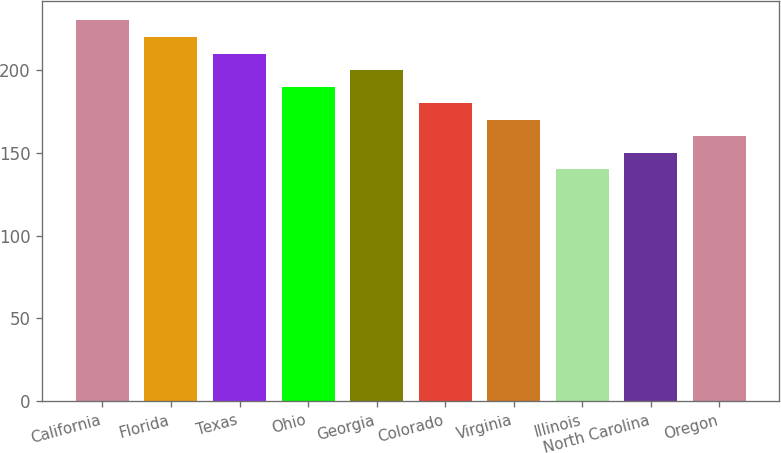<chart> <loc_0><loc_0><loc_500><loc_500><bar_chart><fcel>California<fcel>Florida<fcel>Texas<fcel>Ohio<fcel>Georgia<fcel>Colorado<fcel>Virginia<fcel>Illinois<fcel>North Carolina<fcel>Oregon<nl><fcel>229.87<fcel>219.88<fcel>209.89<fcel>189.91<fcel>199.9<fcel>179.92<fcel>169.93<fcel>139.96<fcel>149.95<fcel>159.94<nl></chart> 